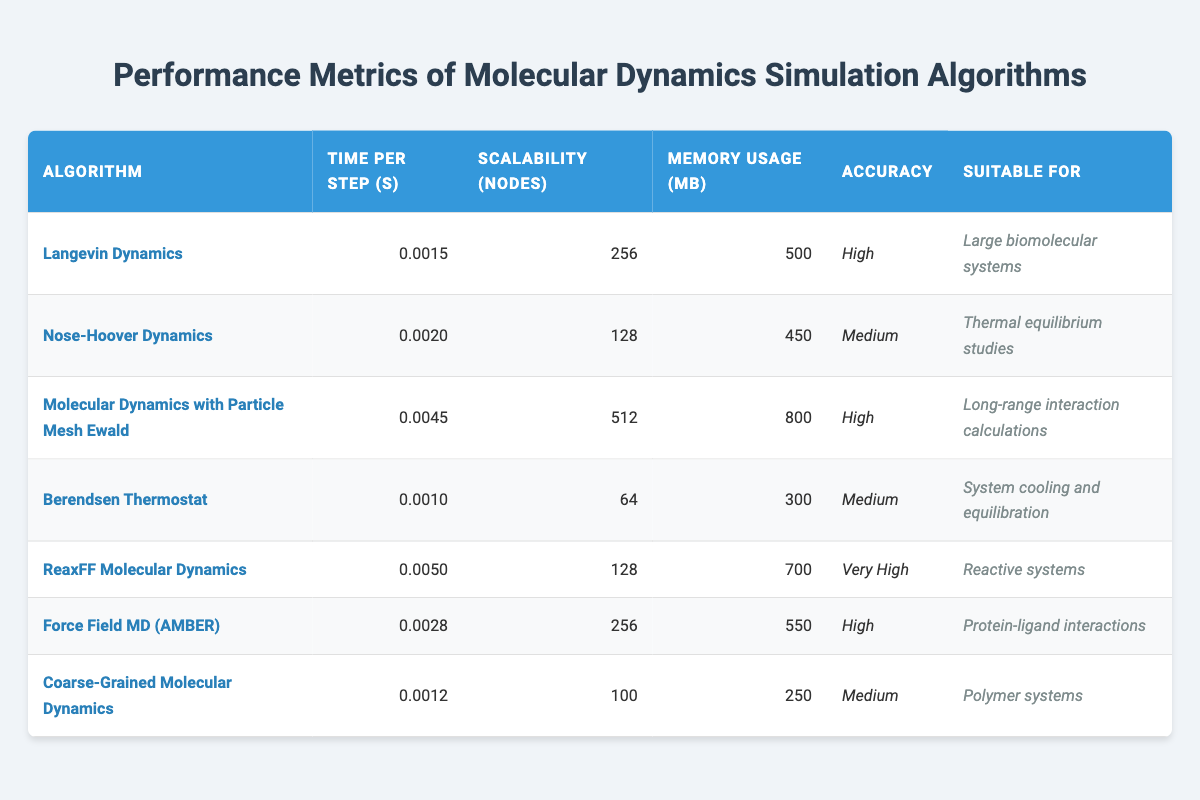What is the memory usage of ReaxFF Molecular Dynamics? The table lists the memory usage for ReaxFF Molecular Dynamics, which shows 700 MB in the corresponding row.
Answer: 700 MB What is the time per step for the Coarse-Grained Molecular Dynamics algorithm? From the table, Coarse-Grained Molecular Dynamics has a time per step value of 0.0012 seconds.
Answer: 0.0012 seconds Which algorithm has the highest scalability? The scalability column shows that Molecular Dynamics with Particle Mesh Ewald has the highest scalability with 512 nodes.
Answer: 512 nodes Is the accuracy of Berendsen Thermostat high? According to the table, Berendsen Thermostat's accuracy is listed as "Medium," so it is not high.
Answer: No What is the average time per step for the algorithms listed? To calculate the average, we sum all time per step values: 0.0015 + 0.0020 + 0.0045 + 0.0010 + 0.0050 + 0.0028 + 0.0012 = 0.0180, and then divide by the number of algorithms (7), resulting in an average of 0.0180/7 = 0.00257 seconds, approximately.
Answer: 0.00257 seconds How many algorithms have medium accuracy? By reviewing the table, we find that Nose-Hoover Dynamics, Berendsen Thermostat, and Coarse-Grained Molecular Dynamics all have "Medium" accuracy. Thus, there are 3 algorithms listed as medium accuracy.
Answer: 3 Which algorithm is suitable for large biomolecular systems? The table indicates that Langevin Dynamics is suitable for large biomolecular systems, as noted in its description under the "Suitable For" column.
Answer: Langevin Dynamics What is the difference in memory usage between the highest and lowest memory consuming algorithms? The highest memory usage is 800 MB (Molecular Dynamics with Particle Mesh Ewald), and the lowest is 250 MB (Coarse-Grained Molecular Dynamics). The difference is calculated as 800 - 250 = 550 MB.
Answer: 550 MB What algorithms have high accuracy? Referring to the accuracy column, the algorithms listed as having high accuracy are Langevin Dynamics, Molecular Dynamics with Particle Mesh Ewald, and Force Field MD (AMBER). Thus, there are 3 algorithms with high accuracy.
Answer: 3 If we consider scalability, which algorithm is best suited for long-range interaction calculations? The algorithm designed for long-range interaction calculations is Molecular Dynamics with Particle Mesh Ewald, and it has a scalability of 512 nodes, making it suitable for those purposes.
Answer: Molecular Dynamics with Particle Mesh Ewald What is the total number of nodes required by all algorithms combined? To find the total nodes, we can sum their scalability values: 256 + 128 + 512 + 64 + 128 + 256 + 100 = 1452 nodes.
Answer: 1452 nodes 